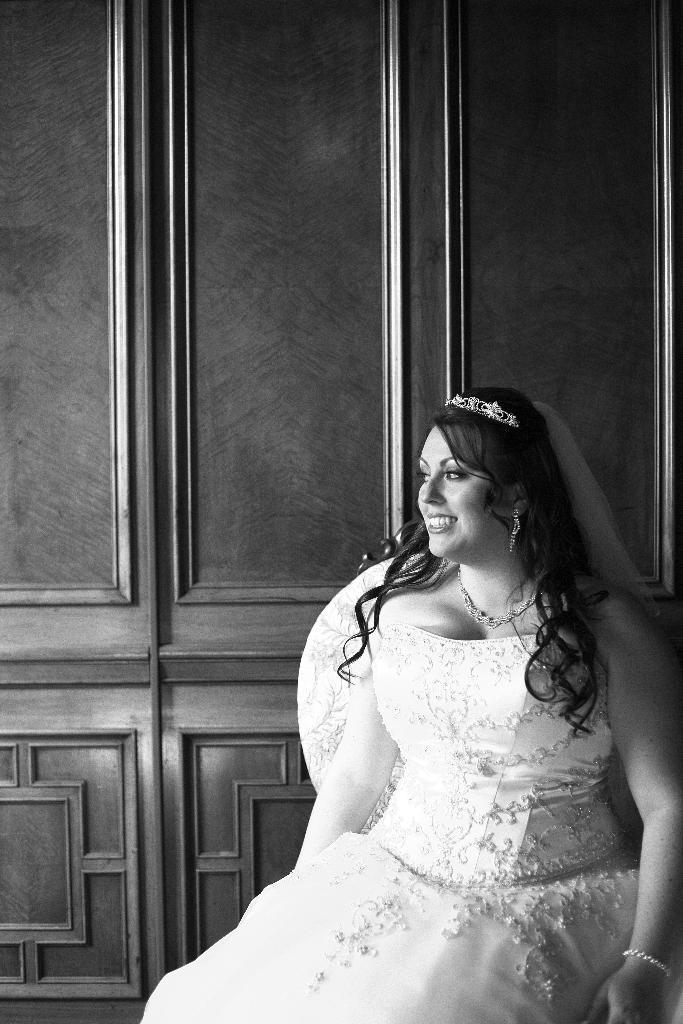What is the main subject in the foreground of the image? There is a person sitting in the foreground of the image. What is the person wearing? The person is wearing a white dress. What type of material can be seen in the background of the image? There is a wooden wall in the background of the image. What type of business is being conducted in the image? There is no indication of any business activity in the image. Can you tell me what the person's dad looks like in the image? There is no other person present in the image, so it is not possible to determine what the person's dad looks like. 